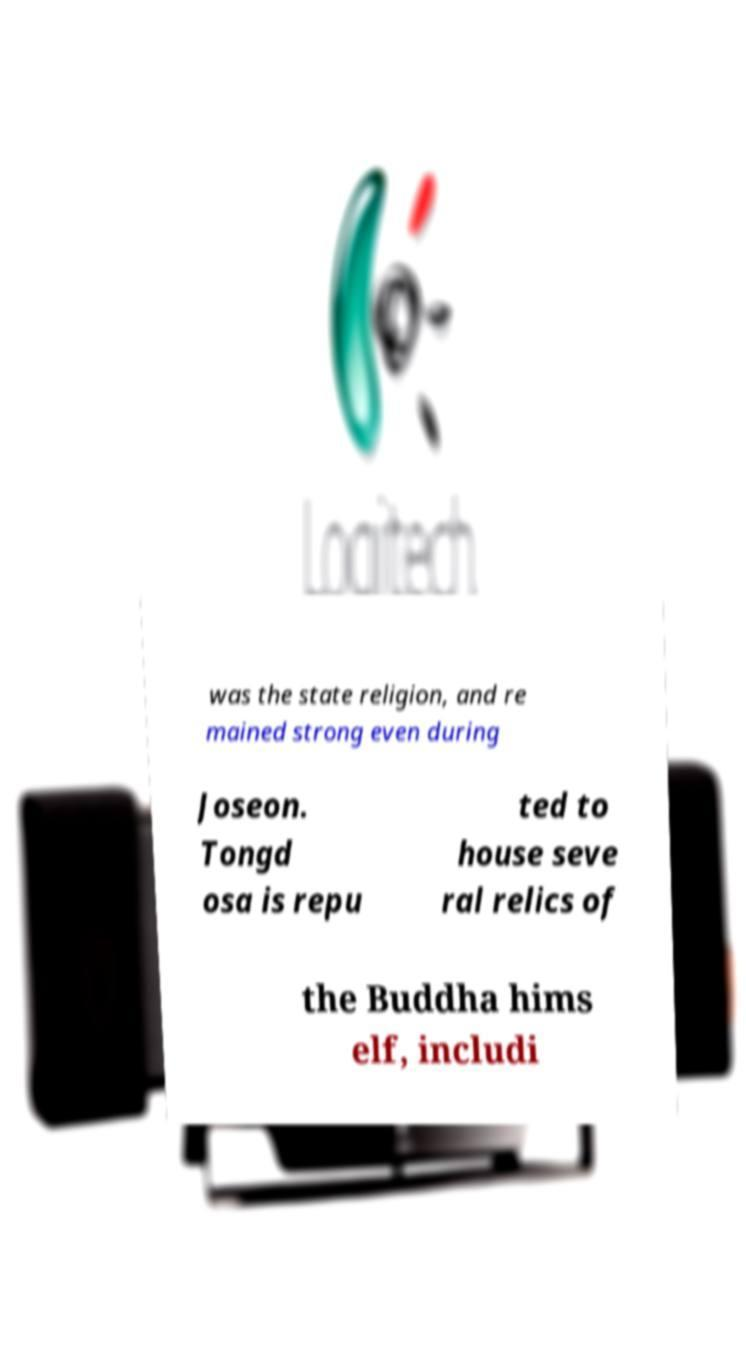Can you read and provide the text displayed in the image?This photo seems to have some interesting text. Can you extract and type it out for me? was the state religion, and re mained strong even during Joseon. Tongd osa is repu ted to house seve ral relics of the Buddha hims elf, includi 